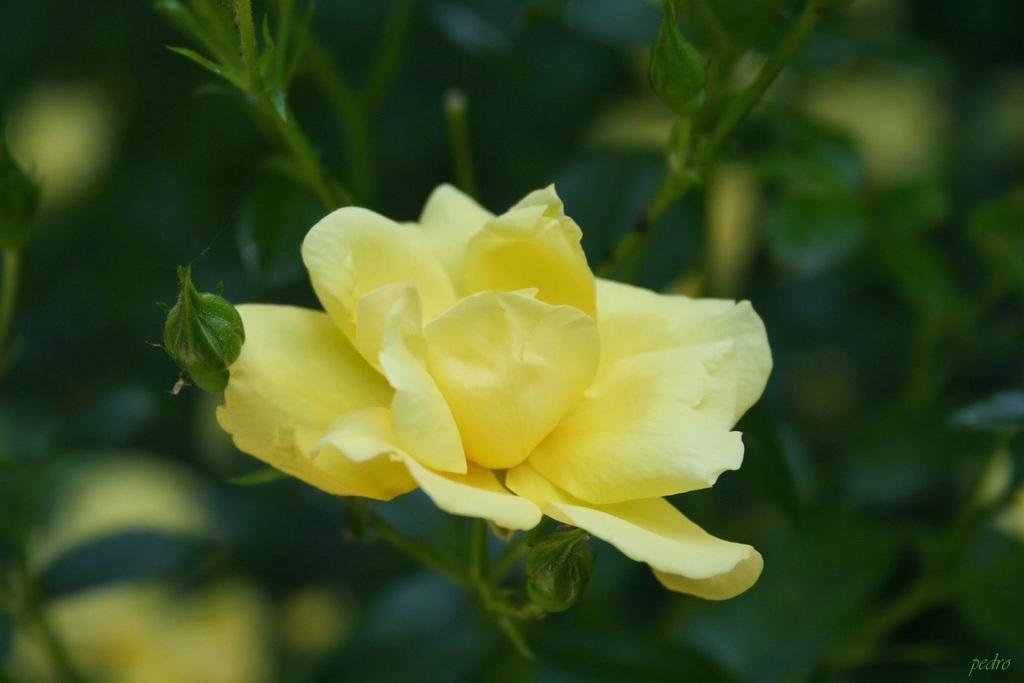Could you give a brief overview of what you see in this image? There is a plant with a yellow color flower. In the background the image is blur but we can see flowers and leaves. 